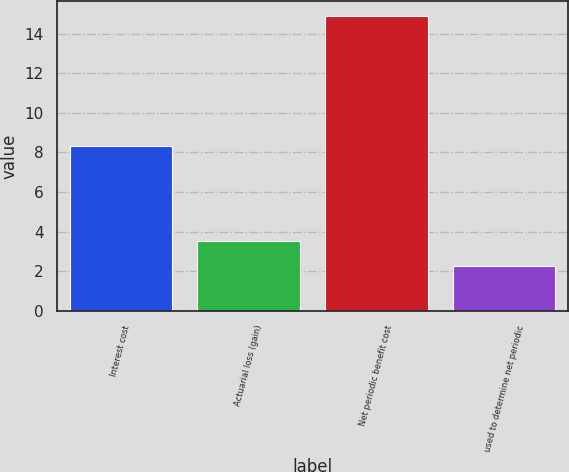<chart> <loc_0><loc_0><loc_500><loc_500><bar_chart><fcel>Interest cost<fcel>Actuarial loss (gain)<fcel>Net periodic benefit cost<fcel>used to determine net periodic<nl><fcel>8.3<fcel>3.52<fcel>14.9<fcel>2.25<nl></chart> 